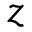Convert formula to latex. <formula><loc_0><loc_0><loc_500><loc_500>z</formula> 